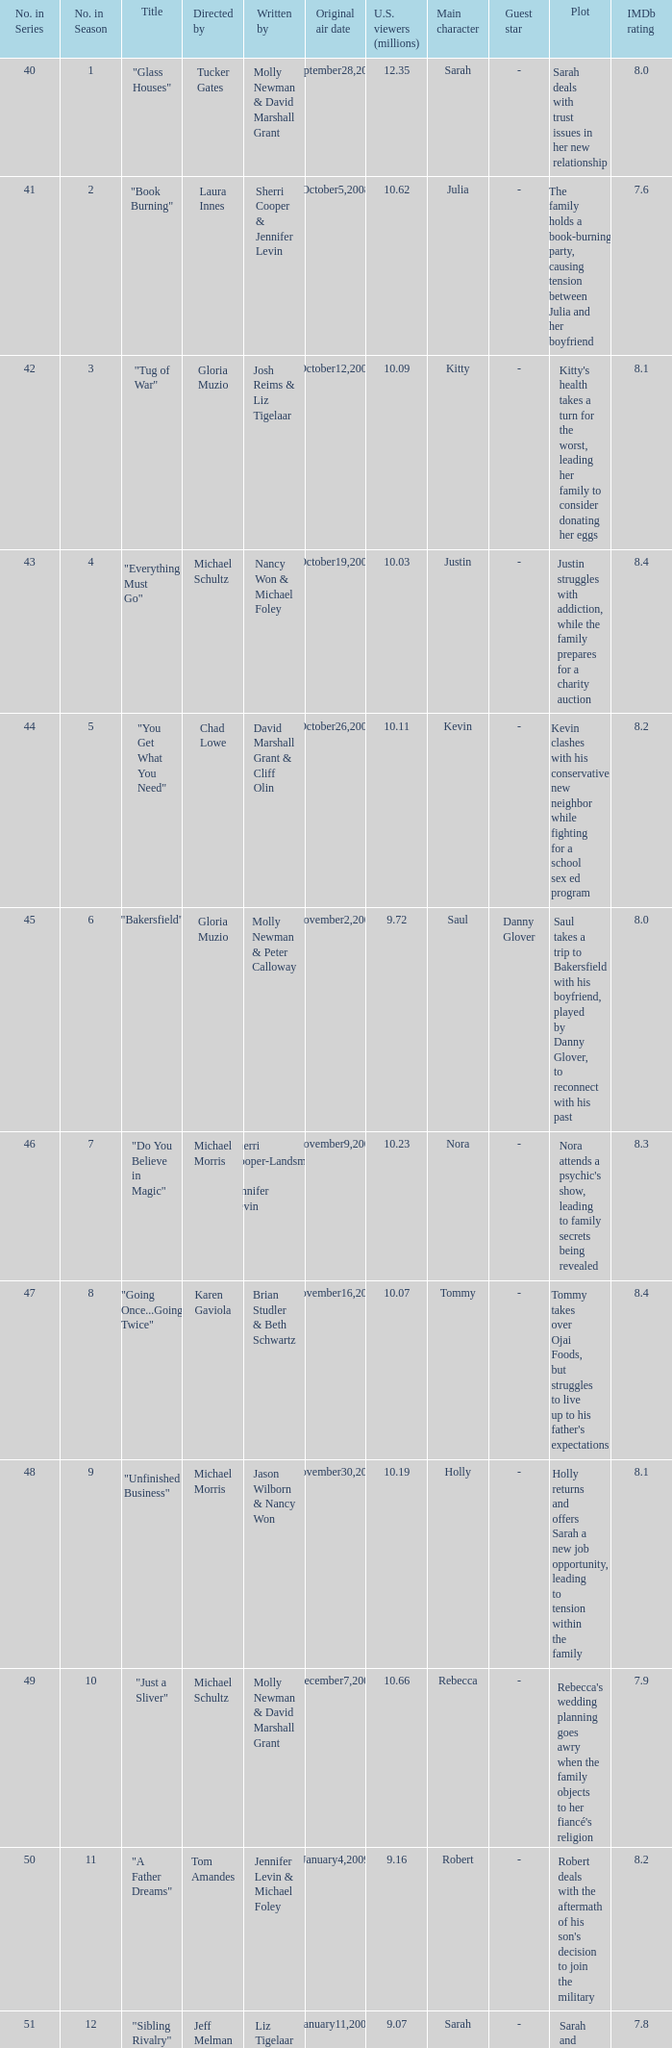When did the episode viewed by 10.50 millions of people in the US run for the first time? March8,2009. 